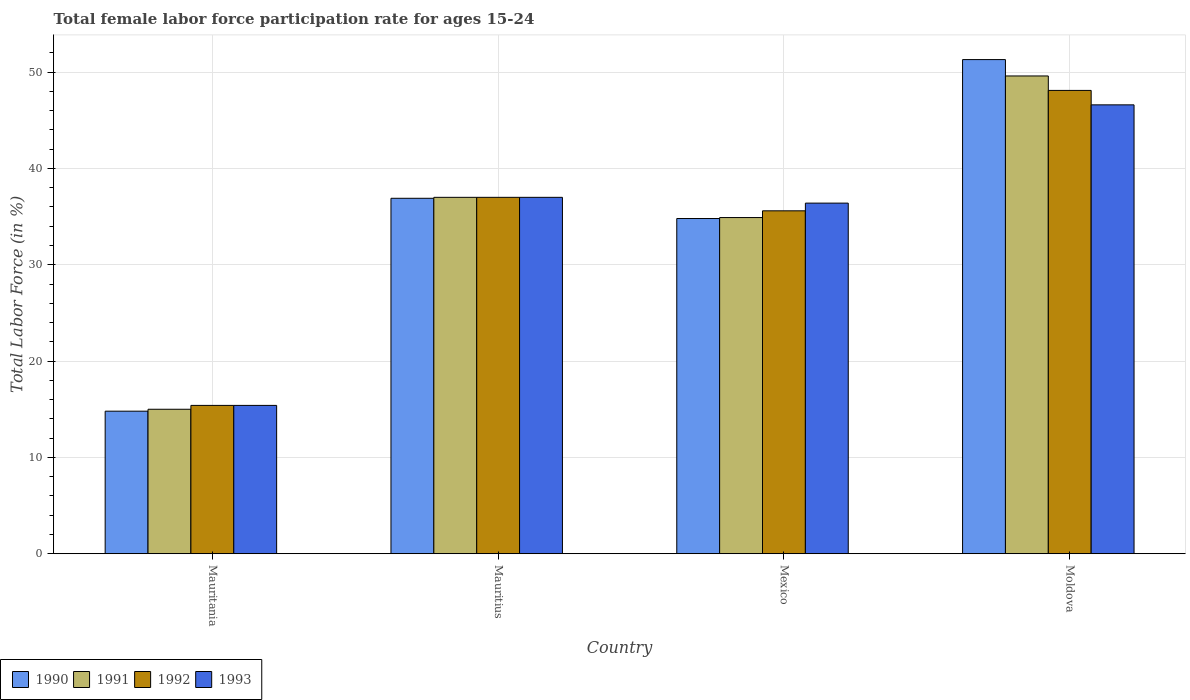How many groups of bars are there?
Your answer should be compact. 4. Are the number of bars per tick equal to the number of legend labels?
Offer a terse response. Yes. How many bars are there on the 4th tick from the right?
Offer a very short reply. 4. What is the label of the 2nd group of bars from the left?
Your answer should be compact. Mauritius. In how many cases, is the number of bars for a given country not equal to the number of legend labels?
Offer a terse response. 0. What is the female labor force participation rate in 1990 in Mauritania?
Give a very brief answer. 14.8. Across all countries, what is the maximum female labor force participation rate in 1992?
Offer a terse response. 48.1. Across all countries, what is the minimum female labor force participation rate in 1992?
Make the answer very short. 15.4. In which country was the female labor force participation rate in 1993 maximum?
Your answer should be compact. Moldova. In which country was the female labor force participation rate in 1991 minimum?
Provide a short and direct response. Mauritania. What is the total female labor force participation rate in 1992 in the graph?
Provide a succinct answer. 136.1. What is the difference between the female labor force participation rate in 1992 in Mauritius and that in Moldova?
Ensure brevity in your answer.  -11.1. What is the difference between the female labor force participation rate in 1990 in Moldova and the female labor force participation rate in 1992 in Mexico?
Keep it short and to the point. 15.7. What is the average female labor force participation rate in 1990 per country?
Your answer should be very brief. 34.45. What is the difference between the female labor force participation rate of/in 1992 and female labor force participation rate of/in 1991 in Mexico?
Give a very brief answer. 0.7. What is the ratio of the female labor force participation rate in 1991 in Mexico to that in Moldova?
Keep it short and to the point. 0.7. Is the difference between the female labor force participation rate in 1992 in Mauritania and Moldova greater than the difference between the female labor force participation rate in 1991 in Mauritania and Moldova?
Your response must be concise. Yes. What is the difference between the highest and the second highest female labor force participation rate in 1991?
Your answer should be compact. 14.7. What is the difference between the highest and the lowest female labor force participation rate in 1991?
Give a very brief answer. 34.6. Is the sum of the female labor force participation rate in 1990 in Mauritania and Mexico greater than the maximum female labor force participation rate in 1991 across all countries?
Make the answer very short. Yes. Is it the case that in every country, the sum of the female labor force participation rate in 1990 and female labor force participation rate in 1991 is greater than the sum of female labor force participation rate in 1993 and female labor force participation rate in 1992?
Keep it short and to the point. No. What does the 2nd bar from the left in Mauritius represents?
Offer a terse response. 1991. What does the 2nd bar from the right in Mauritania represents?
Your response must be concise. 1992. How many bars are there?
Give a very brief answer. 16. Does the graph contain grids?
Offer a terse response. Yes. Where does the legend appear in the graph?
Make the answer very short. Bottom left. How many legend labels are there?
Your answer should be compact. 4. What is the title of the graph?
Provide a short and direct response. Total female labor force participation rate for ages 15-24. Does "2005" appear as one of the legend labels in the graph?
Give a very brief answer. No. What is the Total Labor Force (in %) of 1990 in Mauritania?
Provide a succinct answer. 14.8. What is the Total Labor Force (in %) of 1991 in Mauritania?
Give a very brief answer. 15. What is the Total Labor Force (in %) of 1992 in Mauritania?
Provide a succinct answer. 15.4. What is the Total Labor Force (in %) of 1993 in Mauritania?
Give a very brief answer. 15.4. What is the Total Labor Force (in %) in 1990 in Mauritius?
Give a very brief answer. 36.9. What is the Total Labor Force (in %) of 1993 in Mauritius?
Offer a terse response. 37. What is the Total Labor Force (in %) in 1990 in Mexico?
Your answer should be compact. 34.8. What is the Total Labor Force (in %) in 1991 in Mexico?
Make the answer very short. 34.9. What is the Total Labor Force (in %) of 1992 in Mexico?
Give a very brief answer. 35.6. What is the Total Labor Force (in %) in 1993 in Mexico?
Your response must be concise. 36.4. What is the Total Labor Force (in %) of 1990 in Moldova?
Provide a succinct answer. 51.3. What is the Total Labor Force (in %) in 1991 in Moldova?
Offer a terse response. 49.6. What is the Total Labor Force (in %) of 1992 in Moldova?
Make the answer very short. 48.1. What is the Total Labor Force (in %) in 1993 in Moldova?
Your answer should be very brief. 46.6. Across all countries, what is the maximum Total Labor Force (in %) of 1990?
Provide a succinct answer. 51.3. Across all countries, what is the maximum Total Labor Force (in %) in 1991?
Provide a succinct answer. 49.6. Across all countries, what is the maximum Total Labor Force (in %) in 1992?
Ensure brevity in your answer.  48.1. Across all countries, what is the maximum Total Labor Force (in %) in 1993?
Give a very brief answer. 46.6. Across all countries, what is the minimum Total Labor Force (in %) in 1990?
Offer a terse response. 14.8. Across all countries, what is the minimum Total Labor Force (in %) in 1991?
Keep it short and to the point. 15. Across all countries, what is the minimum Total Labor Force (in %) of 1992?
Make the answer very short. 15.4. Across all countries, what is the minimum Total Labor Force (in %) in 1993?
Keep it short and to the point. 15.4. What is the total Total Labor Force (in %) in 1990 in the graph?
Give a very brief answer. 137.8. What is the total Total Labor Force (in %) in 1991 in the graph?
Make the answer very short. 136.5. What is the total Total Labor Force (in %) of 1992 in the graph?
Provide a short and direct response. 136.1. What is the total Total Labor Force (in %) in 1993 in the graph?
Your answer should be very brief. 135.4. What is the difference between the Total Labor Force (in %) of 1990 in Mauritania and that in Mauritius?
Give a very brief answer. -22.1. What is the difference between the Total Labor Force (in %) in 1991 in Mauritania and that in Mauritius?
Make the answer very short. -22. What is the difference between the Total Labor Force (in %) in 1992 in Mauritania and that in Mauritius?
Keep it short and to the point. -21.6. What is the difference between the Total Labor Force (in %) in 1993 in Mauritania and that in Mauritius?
Offer a terse response. -21.6. What is the difference between the Total Labor Force (in %) of 1991 in Mauritania and that in Mexico?
Your answer should be very brief. -19.9. What is the difference between the Total Labor Force (in %) in 1992 in Mauritania and that in Mexico?
Make the answer very short. -20.2. What is the difference between the Total Labor Force (in %) of 1990 in Mauritania and that in Moldova?
Provide a succinct answer. -36.5. What is the difference between the Total Labor Force (in %) in 1991 in Mauritania and that in Moldova?
Make the answer very short. -34.6. What is the difference between the Total Labor Force (in %) of 1992 in Mauritania and that in Moldova?
Ensure brevity in your answer.  -32.7. What is the difference between the Total Labor Force (in %) of 1993 in Mauritania and that in Moldova?
Provide a succinct answer. -31.2. What is the difference between the Total Labor Force (in %) in 1990 in Mauritius and that in Mexico?
Your answer should be very brief. 2.1. What is the difference between the Total Labor Force (in %) in 1991 in Mauritius and that in Mexico?
Offer a terse response. 2.1. What is the difference between the Total Labor Force (in %) of 1992 in Mauritius and that in Mexico?
Offer a terse response. 1.4. What is the difference between the Total Labor Force (in %) of 1993 in Mauritius and that in Mexico?
Make the answer very short. 0.6. What is the difference between the Total Labor Force (in %) of 1990 in Mauritius and that in Moldova?
Your answer should be compact. -14.4. What is the difference between the Total Labor Force (in %) of 1993 in Mauritius and that in Moldova?
Your answer should be very brief. -9.6. What is the difference between the Total Labor Force (in %) of 1990 in Mexico and that in Moldova?
Offer a very short reply. -16.5. What is the difference between the Total Labor Force (in %) in 1991 in Mexico and that in Moldova?
Offer a very short reply. -14.7. What is the difference between the Total Labor Force (in %) in 1992 in Mexico and that in Moldova?
Your answer should be compact. -12.5. What is the difference between the Total Labor Force (in %) of 1993 in Mexico and that in Moldova?
Provide a succinct answer. -10.2. What is the difference between the Total Labor Force (in %) of 1990 in Mauritania and the Total Labor Force (in %) of 1991 in Mauritius?
Your answer should be very brief. -22.2. What is the difference between the Total Labor Force (in %) of 1990 in Mauritania and the Total Labor Force (in %) of 1992 in Mauritius?
Give a very brief answer. -22.2. What is the difference between the Total Labor Force (in %) of 1990 in Mauritania and the Total Labor Force (in %) of 1993 in Mauritius?
Your answer should be very brief. -22.2. What is the difference between the Total Labor Force (in %) in 1991 in Mauritania and the Total Labor Force (in %) in 1992 in Mauritius?
Your answer should be very brief. -22. What is the difference between the Total Labor Force (in %) of 1992 in Mauritania and the Total Labor Force (in %) of 1993 in Mauritius?
Keep it short and to the point. -21.6. What is the difference between the Total Labor Force (in %) in 1990 in Mauritania and the Total Labor Force (in %) in 1991 in Mexico?
Offer a terse response. -20.1. What is the difference between the Total Labor Force (in %) of 1990 in Mauritania and the Total Labor Force (in %) of 1992 in Mexico?
Keep it short and to the point. -20.8. What is the difference between the Total Labor Force (in %) in 1990 in Mauritania and the Total Labor Force (in %) in 1993 in Mexico?
Give a very brief answer. -21.6. What is the difference between the Total Labor Force (in %) of 1991 in Mauritania and the Total Labor Force (in %) of 1992 in Mexico?
Provide a short and direct response. -20.6. What is the difference between the Total Labor Force (in %) in 1991 in Mauritania and the Total Labor Force (in %) in 1993 in Mexico?
Your answer should be very brief. -21.4. What is the difference between the Total Labor Force (in %) in 1992 in Mauritania and the Total Labor Force (in %) in 1993 in Mexico?
Provide a short and direct response. -21. What is the difference between the Total Labor Force (in %) in 1990 in Mauritania and the Total Labor Force (in %) in 1991 in Moldova?
Provide a succinct answer. -34.8. What is the difference between the Total Labor Force (in %) of 1990 in Mauritania and the Total Labor Force (in %) of 1992 in Moldova?
Your response must be concise. -33.3. What is the difference between the Total Labor Force (in %) of 1990 in Mauritania and the Total Labor Force (in %) of 1993 in Moldova?
Keep it short and to the point. -31.8. What is the difference between the Total Labor Force (in %) in 1991 in Mauritania and the Total Labor Force (in %) in 1992 in Moldova?
Your answer should be very brief. -33.1. What is the difference between the Total Labor Force (in %) of 1991 in Mauritania and the Total Labor Force (in %) of 1993 in Moldova?
Keep it short and to the point. -31.6. What is the difference between the Total Labor Force (in %) in 1992 in Mauritania and the Total Labor Force (in %) in 1993 in Moldova?
Ensure brevity in your answer.  -31.2. What is the difference between the Total Labor Force (in %) in 1990 in Mauritius and the Total Labor Force (in %) in 1992 in Mexico?
Your answer should be very brief. 1.3. What is the difference between the Total Labor Force (in %) in 1990 in Mauritius and the Total Labor Force (in %) in 1993 in Mexico?
Your answer should be very brief. 0.5. What is the difference between the Total Labor Force (in %) in 1991 in Mauritius and the Total Labor Force (in %) in 1992 in Mexico?
Ensure brevity in your answer.  1.4. What is the difference between the Total Labor Force (in %) of 1990 in Mauritius and the Total Labor Force (in %) of 1991 in Moldova?
Provide a short and direct response. -12.7. What is the difference between the Total Labor Force (in %) of 1990 in Mauritius and the Total Labor Force (in %) of 1993 in Moldova?
Your answer should be very brief. -9.7. What is the difference between the Total Labor Force (in %) in 1991 in Mauritius and the Total Labor Force (in %) in 1992 in Moldova?
Your response must be concise. -11.1. What is the difference between the Total Labor Force (in %) of 1991 in Mauritius and the Total Labor Force (in %) of 1993 in Moldova?
Give a very brief answer. -9.6. What is the difference between the Total Labor Force (in %) of 1992 in Mauritius and the Total Labor Force (in %) of 1993 in Moldova?
Your answer should be very brief. -9.6. What is the difference between the Total Labor Force (in %) in 1990 in Mexico and the Total Labor Force (in %) in 1991 in Moldova?
Your response must be concise. -14.8. What is the difference between the Total Labor Force (in %) in 1990 in Mexico and the Total Labor Force (in %) in 1992 in Moldova?
Keep it short and to the point. -13.3. What is the difference between the Total Labor Force (in %) in 1991 in Mexico and the Total Labor Force (in %) in 1992 in Moldova?
Give a very brief answer. -13.2. What is the average Total Labor Force (in %) of 1990 per country?
Your answer should be compact. 34.45. What is the average Total Labor Force (in %) in 1991 per country?
Provide a succinct answer. 34.12. What is the average Total Labor Force (in %) of 1992 per country?
Your answer should be very brief. 34.02. What is the average Total Labor Force (in %) in 1993 per country?
Keep it short and to the point. 33.85. What is the difference between the Total Labor Force (in %) in 1990 and Total Labor Force (in %) in 1991 in Mauritania?
Your answer should be compact. -0.2. What is the difference between the Total Labor Force (in %) in 1990 and Total Labor Force (in %) in 1992 in Mauritania?
Your answer should be compact. -0.6. What is the difference between the Total Labor Force (in %) in 1990 and Total Labor Force (in %) in 1993 in Mauritania?
Ensure brevity in your answer.  -0.6. What is the difference between the Total Labor Force (in %) of 1991 and Total Labor Force (in %) of 1993 in Mauritania?
Your answer should be compact. -0.4. What is the difference between the Total Labor Force (in %) of 1992 and Total Labor Force (in %) of 1993 in Mauritania?
Make the answer very short. 0. What is the difference between the Total Labor Force (in %) in 1990 and Total Labor Force (in %) in 1992 in Mauritius?
Give a very brief answer. -0.1. What is the difference between the Total Labor Force (in %) in 1990 and Total Labor Force (in %) in 1993 in Mauritius?
Make the answer very short. -0.1. What is the difference between the Total Labor Force (in %) of 1991 and Total Labor Force (in %) of 1992 in Mauritius?
Provide a short and direct response. 0. What is the difference between the Total Labor Force (in %) in 1991 and Total Labor Force (in %) in 1993 in Mauritius?
Offer a terse response. 0. What is the difference between the Total Labor Force (in %) in 1990 and Total Labor Force (in %) in 1993 in Mexico?
Provide a short and direct response. -1.6. What is the difference between the Total Labor Force (in %) in 1991 and Total Labor Force (in %) in 1993 in Mexico?
Keep it short and to the point. -1.5. What is the difference between the Total Labor Force (in %) of 1992 and Total Labor Force (in %) of 1993 in Mexico?
Your answer should be very brief. -0.8. What is the difference between the Total Labor Force (in %) in 1990 and Total Labor Force (in %) in 1991 in Moldova?
Your answer should be very brief. 1.7. What is the difference between the Total Labor Force (in %) in 1990 and Total Labor Force (in %) in 1992 in Moldova?
Ensure brevity in your answer.  3.2. What is the difference between the Total Labor Force (in %) of 1992 and Total Labor Force (in %) of 1993 in Moldova?
Ensure brevity in your answer.  1.5. What is the ratio of the Total Labor Force (in %) of 1990 in Mauritania to that in Mauritius?
Make the answer very short. 0.4. What is the ratio of the Total Labor Force (in %) of 1991 in Mauritania to that in Mauritius?
Your answer should be compact. 0.41. What is the ratio of the Total Labor Force (in %) of 1992 in Mauritania to that in Mauritius?
Offer a very short reply. 0.42. What is the ratio of the Total Labor Force (in %) of 1993 in Mauritania to that in Mauritius?
Make the answer very short. 0.42. What is the ratio of the Total Labor Force (in %) in 1990 in Mauritania to that in Mexico?
Your answer should be compact. 0.43. What is the ratio of the Total Labor Force (in %) of 1991 in Mauritania to that in Mexico?
Your response must be concise. 0.43. What is the ratio of the Total Labor Force (in %) in 1992 in Mauritania to that in Mexico?
Ensure brevity in your answer.  0.43. What is the ratio of the Total Labor Force (in %) of 1993 in Mauritania to that in Mexico?
Provide a succinct answer. 0.42. What is the ratio of the Total Labor Force (in %) of 1990 in Mauritania to that in Moldova?
Keep it short and to the point. 0.29. What is the ratio of the Total Labor Force (in %) in 1991 in Mauritania to that in Moldova?
Keep it short and to the point. 0.3. What is the ratio of the Total Labor Force (in %) of 1992 in Mauritania to that in Moldova?
Give a very brief answer. 0.32. What is the ratio of the Total Labor Force (in %) of 1993 in Mauritania to that in Moldova?
Make the answer very short. 0.33. What is the ratio of the Total Labor Force (in %) in 1990 in Mauritius to that in Mexico?
Ensure brevity in your answer.  1.06. What is the ratio of the Total Labor Force (in %) of 1991 in Mauritius to that in Mexico?
Ensure brevity in your answer.  1.06. What is the ratio of the Total Labor Force (in %) in 1992 in Mauritius to that in Mexico?
Ensure brevity in your answer.  1.04. What is the ratio of the Total Labor Force (in %) of 1993 in Mauritius to that in Mexico?
Make the answer very short. 1.02. What is the ratio of the Total Labor Force (in %) of 1990 in Mauritius to that in Moldova?
Provide a succinct answer. 0.72. What is the ratio of the Total Labor Force (in %) in 1991 in Mauritius to that in Moldova?
Your answer should be very brief. 0.75. What is the ratio of the Total Labor Force (in %) in 1992 in Mauritius to that in Moldova?
Offer a very short reply. 0.77. What is the ratio of the Total Labor Force (in %) in 1993 in Mauritius to that in Moldova?
Your response must be concise. 0.79. What is the ratio of the Total Labor Force (in %) in 1990 in Mexico to that in Moldova?
Your answer should be very brief. 0.68. What is the ratio of the Total Labor Force (in %) in 1991 in Mexico to that in Moldova?
Offer a terse response. 0.7. What is the ratio of the Total Labor Force (in %) in 1992 in Mexico to that in Moldova?
Your response must be concise. 0.74. What is the ratio of the Total Labor Force (in %) in 1993 in Mexico to that in Moldova?
Ensure brevity in your answer.  0.78. What is the difference between the highest and the second highest Total Labor Force (in %) of 1991?
Your answer should be very brief. 12.6. What is the difference between the highest and the second highest Total Labor Force (in %) of 1993?
Provide a short and direct response. 9.6. What is the difference between the highest and the lowest Total Labor Force (in %) in 1990?
Provide a short and direct response. 36.5. What is the difference between the highest and the lowest Total Labor Force (in %) in 1991?
Your answer should be very brief. 34.6. What is the difference between the highest and the lowest Total Labor Force (in %) in 1992?
Your answer should be very brief. 32.7. What is the difference between the highest and the lowest Total Labor Force (in %) in 1993?
Your answer should be compact. 31.2. 